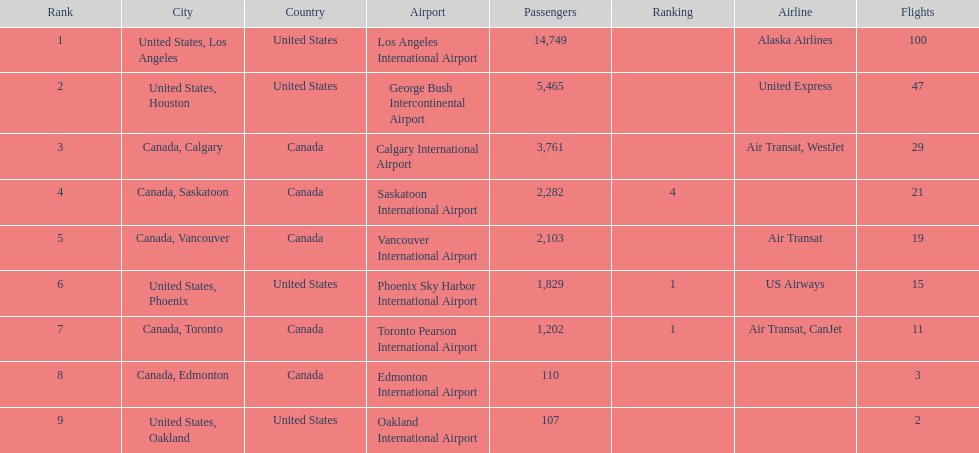Which airline carries the most passengers? Alaska Airlines. 